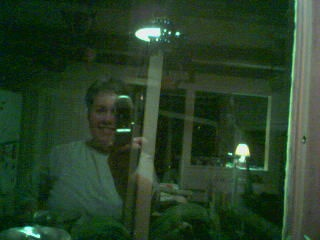Describe the objects in this image and their specific colors. I can see people in black, darkgreen, and teal tones and cell phone in black and darkgreen tones in this image. 